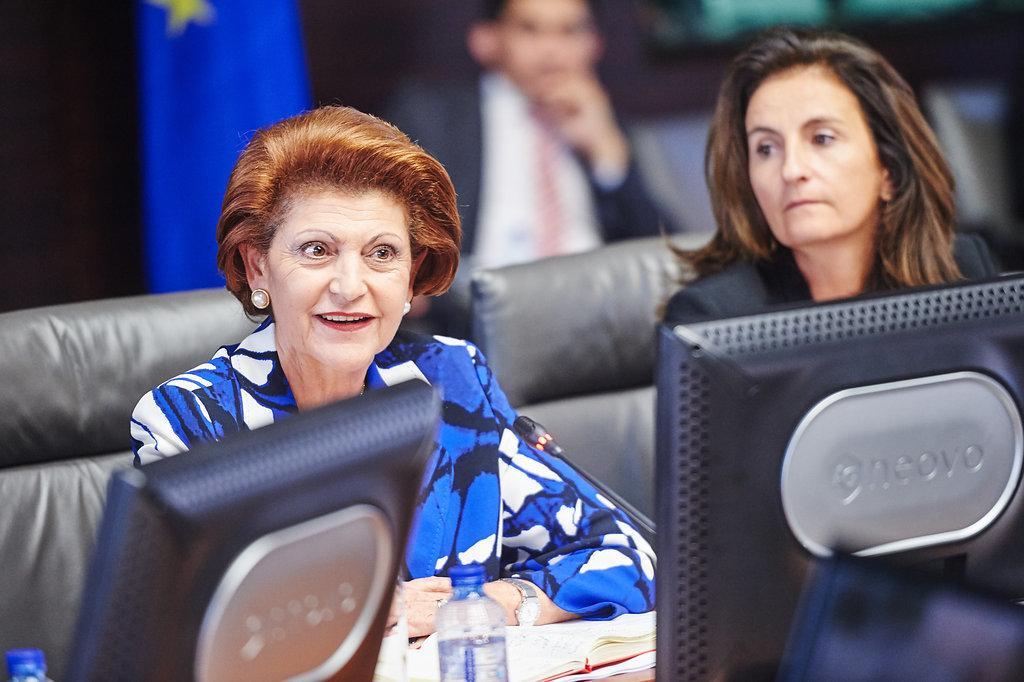Could you give a brief overview of what you see in this image? In this image I can see 2 women sitting. There are monitors, a book and water bottles in front of them. There is a flag and a person at the back. 